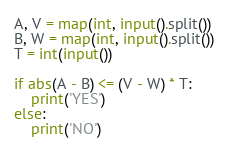<code> <loc_0><loc_0><loc_500><loc_500><_Python_>A, V = map(int, input().split())
B, W = map(int, input().split())
T = int(input())

if abs(A - B) <= (V - W) * T:
    print('YES')
else:
    print('NO')</code> 